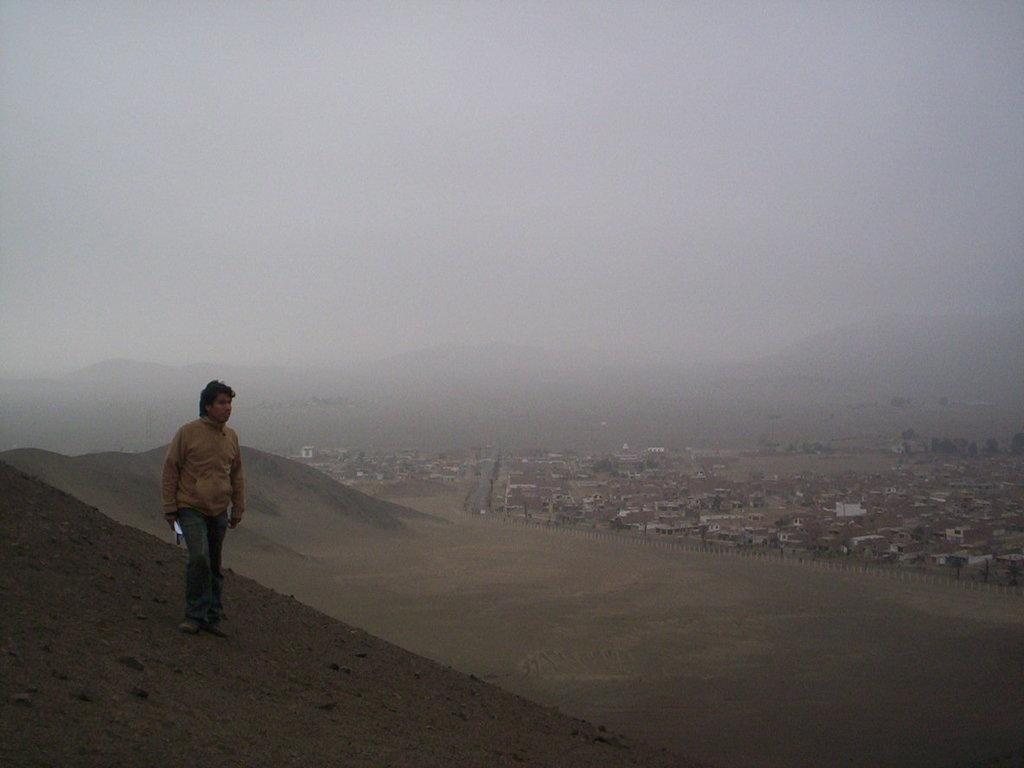What is the man in the image doing? The man is standing in the image. What is the man holding in the image? The man is holding an object. What can be seen in the distance in the image? There is a hill visible in the image. What type of structures can be seen in the background of the image? There are houses in the background of the image. What is visible above the houses in the image? The sky is visible in the background of the image. What theory is the man presenting to the prison in the image? There is no prison present in the image, and the man is not presenting any theory. 